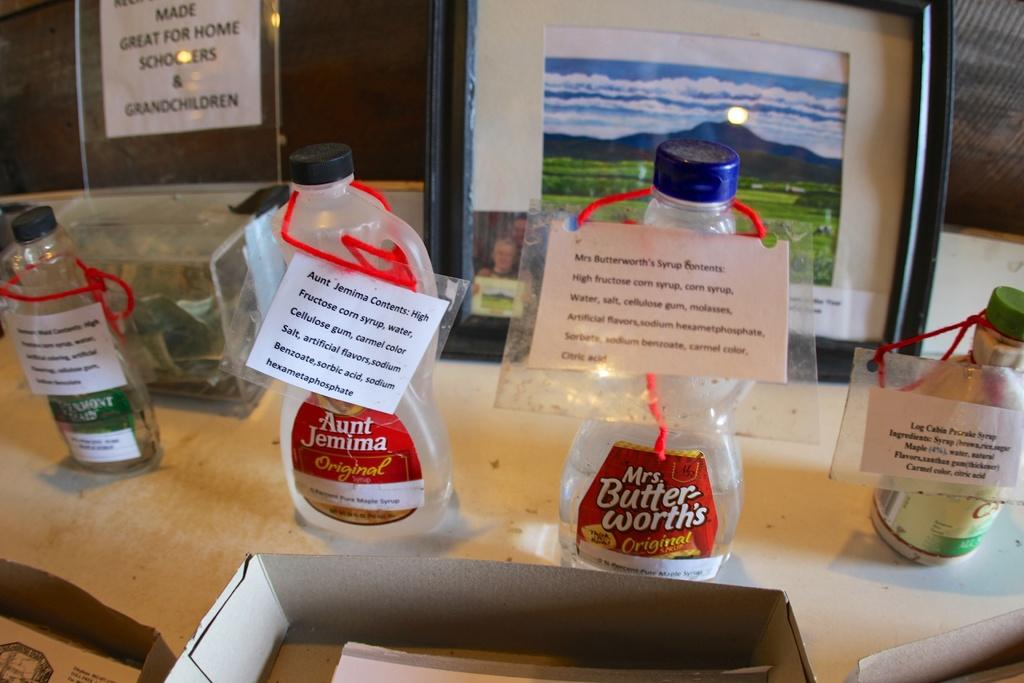<image>
Share a concise interpretation of the image provided. A row of Mrs Butter-worth's and Aunt Jemima syrup bottles are empty and have paper tags. 